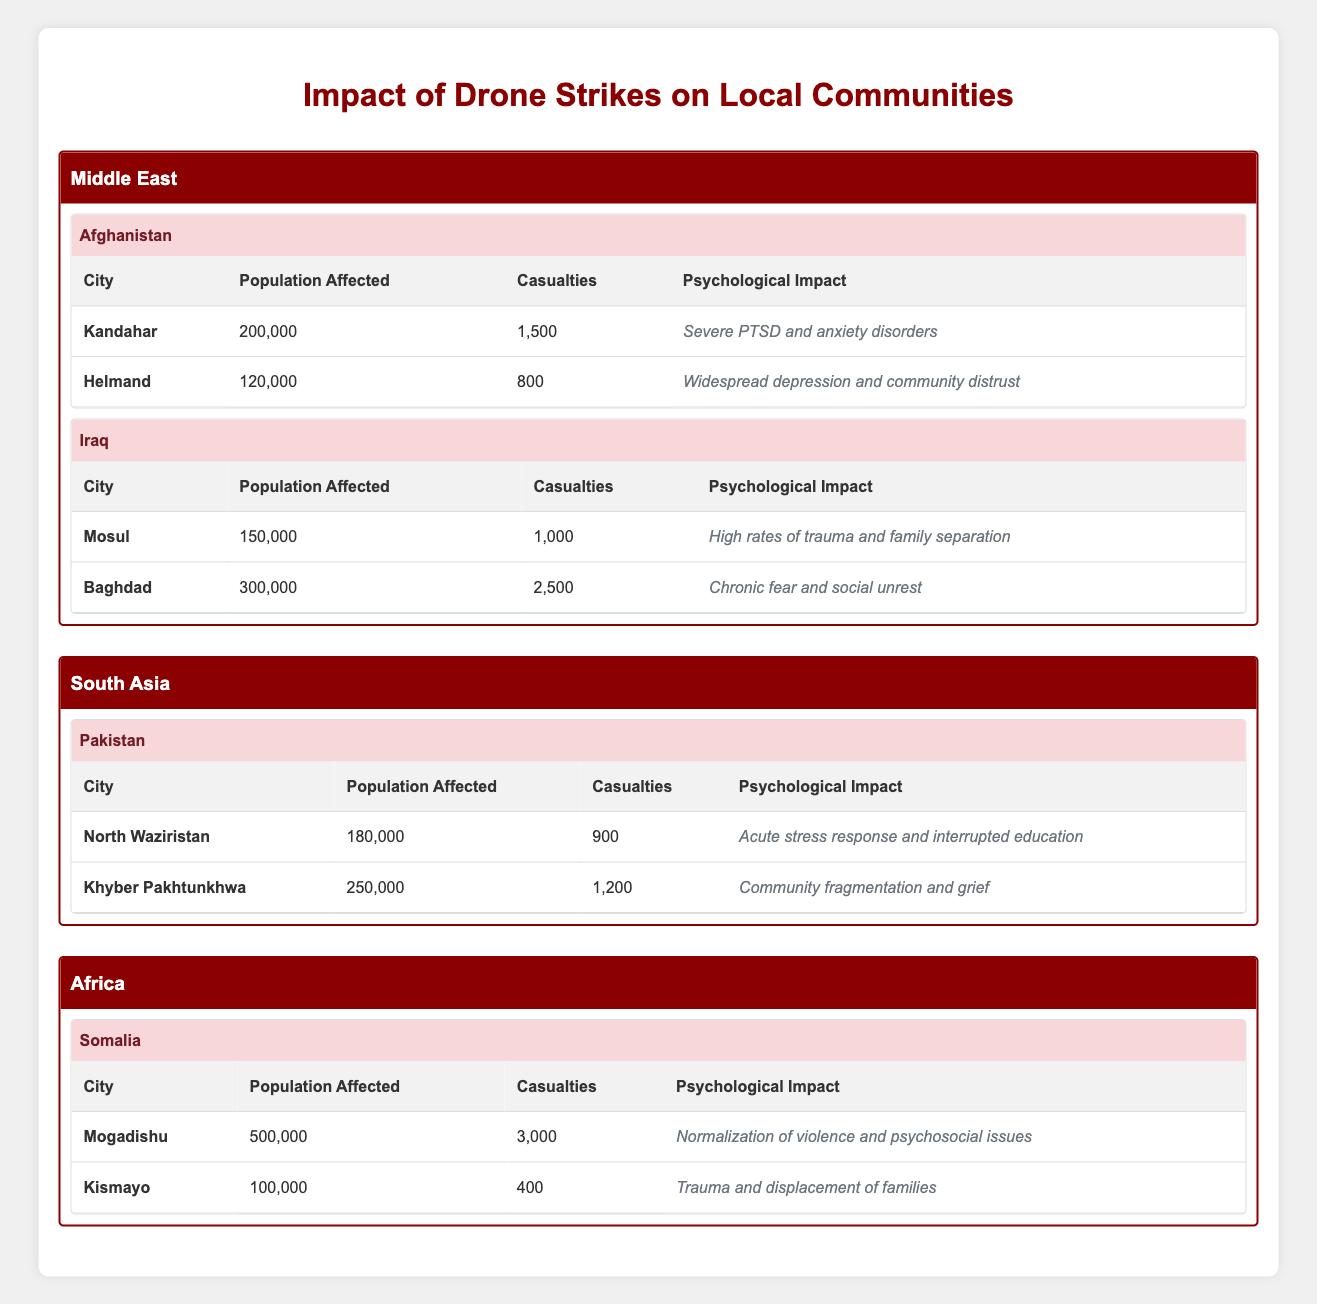What is the total population affected in Afghanistan? The affected populations in Afghanistan's cities are 200,000 (Kandahar) and 120,000 (Helmand). Adding these two figures gives us 200,000 + 120,000 = 320,000.
Answer: 320,000 Which city in Somalia had the highest number of casualties? The casualties reported for Mogadishu is 3,000, and for Kismayo is 400. Comparing these numbers, Mogadishu has the highest casualties.
Answer: Mogadishu Is the psychological impact of drone strikes more severe in Iraq or Afghanistan? The psychological impacts recorded are "High rates of trauma and family separation" for Mosul and "Chronic fear and social unrest" for Baghdad in Iraq, and "Severe PTSD and anxiety disorders" for Kandahar and "Widespread depression and community distrust" for Helmand in Afghanistan. Given that "Severe PTSD and anxiety disorders" is often regarded as a more severe impact, Afghanistan is considered to have a more severe psychological impact.
Answer: Afghanistan How many casualties were reported in the city with the highest population affected? The cities with population affected figures are: Mogadishu (500,000) with 3,000 casualties, Baghdad (300,000) with 2,500 casualties, and Khyber Pakhtunkhwa (250,000) with 1,200 casualties. Since Mogadishu has the highest population affected, we refer to its casualty count of 3,000.
Answer: 3,000 What is the average number of casualties for cities in South Asia? The casualties in South Asia are: 900 (North Waziristan) and 1,200 (Khyber Pakhtunkhwa). The average is calculated as (900 + 1,200) / 2 = 2,100 / 2 = 1,050.
Answer: 1,050 Is it true that more people are affected in Helmand than in Mosul? The populations are 120,000 in Helmand and 150,000 in Mosul. Since 120,000 is less than 150,000, the statement is false.
Answer: No What is the total number of people affected across the cities in the Middle East? The affected populations in the Middle East are: 200,000 (Kandahar), 120,000 (Helmand), 150,000 (Mosul), and 300,000 (Baghdad). Summing these gives 200,000 + 120,000 + 150,000 + 300,000 = 770,000.
Answer: 770,000 Which city has the least population affected and what is its psychological impact? The cities with their populations are: 100,000 for Kismayo and the other cities have higher populations. The psychological impact reported for Kismayo is "Trauma and displacement of families".
Answer: Kismayo, Trauma and displacement of families How does the psychological impact differ between the cities of Somalia? Mogadishu has "Normalization of violence and psychosocial issues", while Kismayo has "Trauma and displacement of families". The first suggests a broader societal issue, while the second emphasizes personal and familial trauma, showing different types of impacts.
Answer: There are different types of psychological impacts 